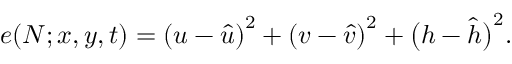<formula> <loc_0><loc_0><loc_500><loc_500>e ( N ; x , y , t ) = \left ( u - \hat { u } \right ) ^ { 2 } + \left ( v - \hat { v } \right ) ^ { 2 } + \left ( h - \hat { h } \right ) ^ { 2 } .</formula> 